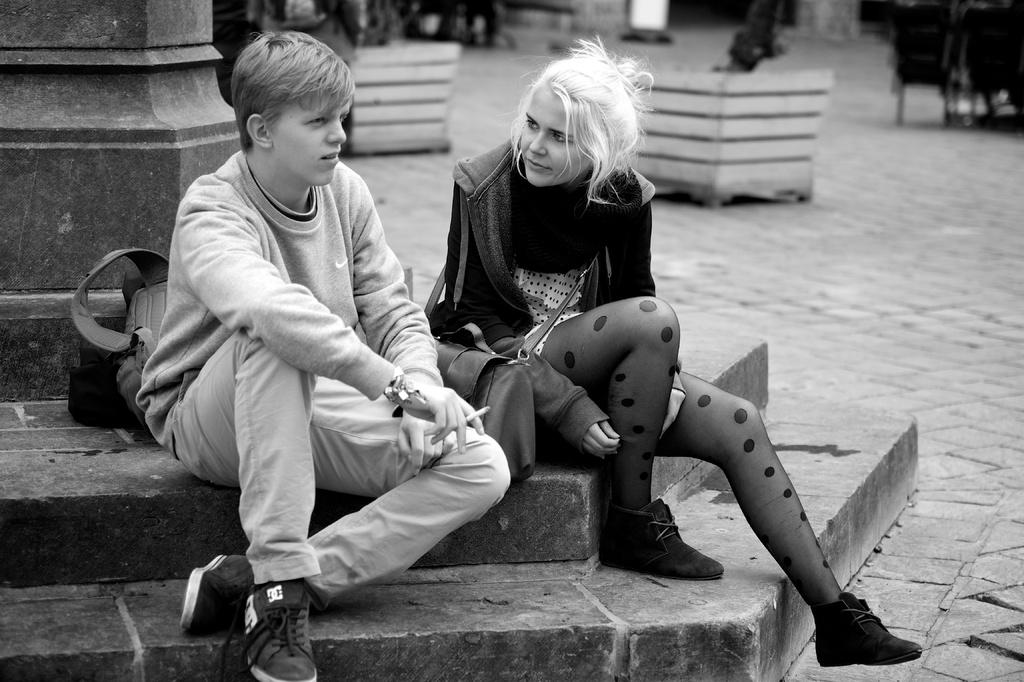What are the two people in the image doing? The two people are sitting on the staircase. What can be seen on the ground in the image? There are objects on the ground. What architectural feature is present in the image? There is a pillar in the image. Where is the backpack located in the image? The backpack is at the right side of the image. What type of jeans are the women wearing in the image? There are no women or jeans present in the image; it features two people sitting on a staircase. 